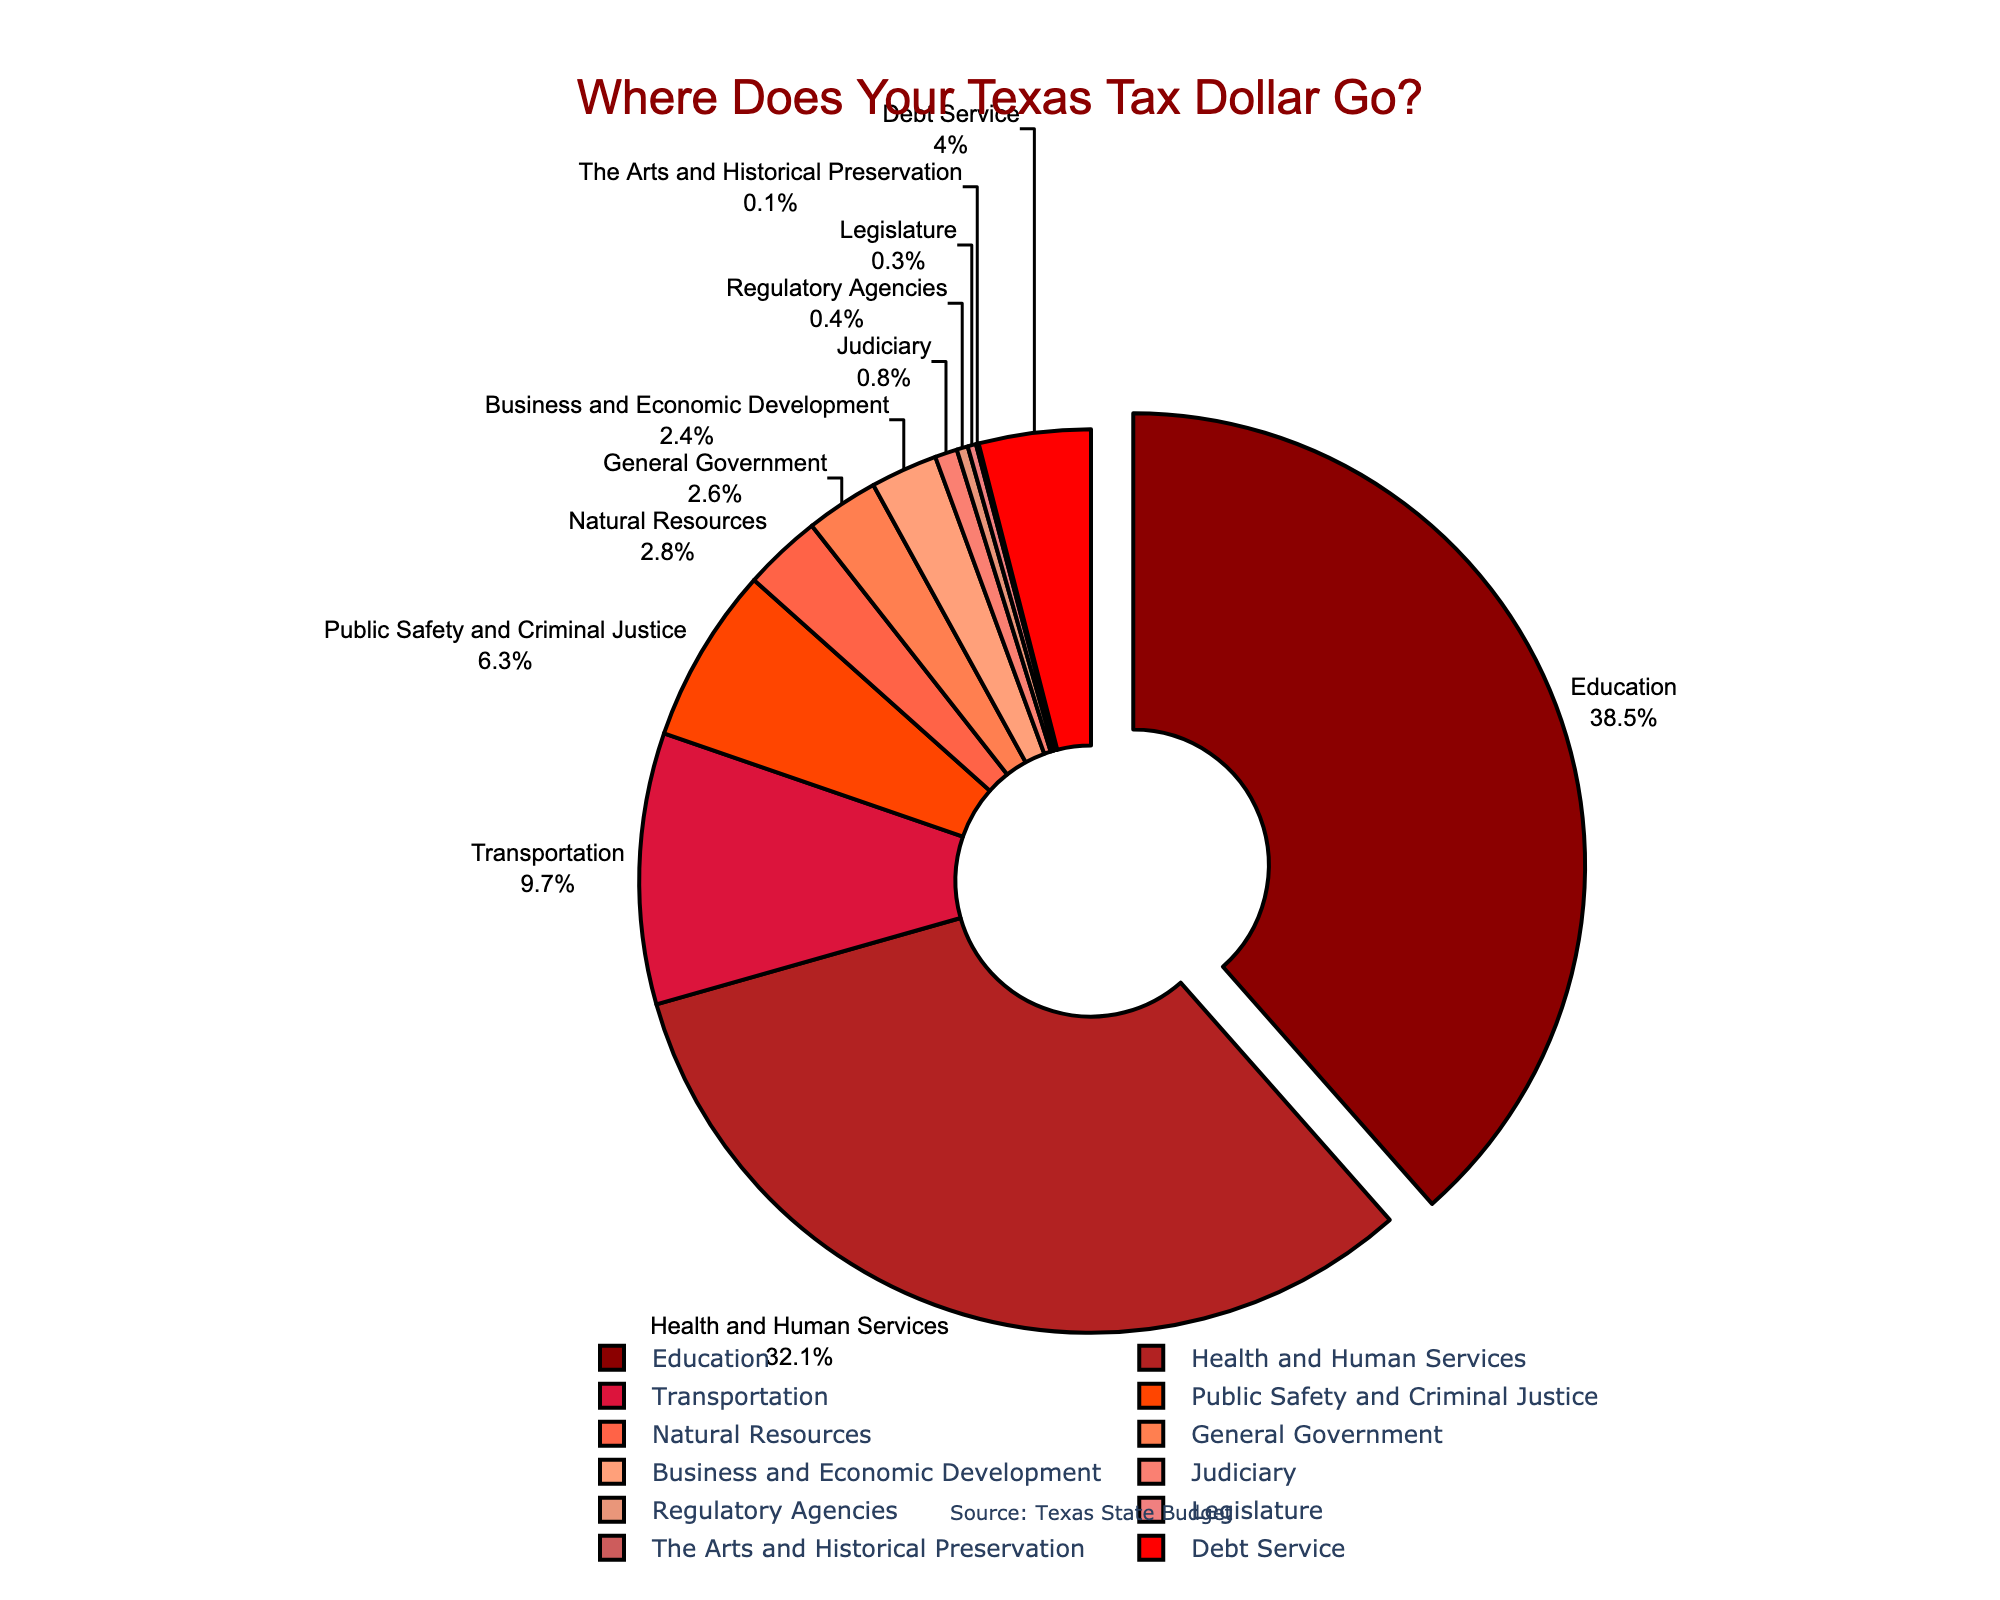Which sector gets the largest portion of Texas state tax revenue? The largest portion is indicated by the sector with the highest percentage. In the pie chart, the segment that is pulled out represents the largest portion. This segment is labeled "Education" with 38.5%.
Answer: Education What is the total percentage of Texas state tax revenue allocated to Health and Human Services and Public Safety and Criminal Justice combined? The percentages for Health and Human Services (32.1%) and Public Safety and Criminal Justice (6.3%) need to be added together: 32.1 + 6.3 = 38.4%.
Answer: 38.4% Is more tax revenue allocated to Transportation or Debt Service? From the pie chart, compare the percentages for Transportation (9.7%) and Debt Service (4.0%). Transportation has a higher percentage.
Answer: Transportation What is the difference in percentage allocation between Education and Health and Human Services? Subtract the percentage of Health and Human Services (32.1%) from the percentage of Education (38.5%): 38.5 - 32.1 = 6.4%.
Answer: 6.4% How many sectors have a tax revenue allocation of less than 1%? The pie chart shows sectors with their percentage allocations. The sectors with percentages less than 1% are Judiciary (0.8%), Regulatory Agencies (0.4%), Legislature (0.3%), and The Arts and Historical Preservation (0.1%). There are 4 such sectors.
Answer: 4 Which sector receives the smallest portion of Texas state tax revenue? The smallest portion is indicated by the smallest percentage. In the pie chart, the segment labeled "The Arts and Historical Preservation" has the smallest percentage at 0.1%.
Answer: The Arts and Historical Preservation What percentage of tax revenue is allocated to sectors other than Education and Health and Human Services? To find this, first, add the percentages for Education (38.5%) and Health and Human Services (32.1%), which totals 70.6%. Then, subtract from 100%: 100 - 70.6 = 29.4%.
Answer: 29.4% What percentage of tax revenue is allocated to General Government and Natural Resources combined? The percentages for General Government (2.6%) and Natural Resources (2.8%) need to be added together: 2.6 + 2.8 = 5.4%.
Answer: 5.4% 